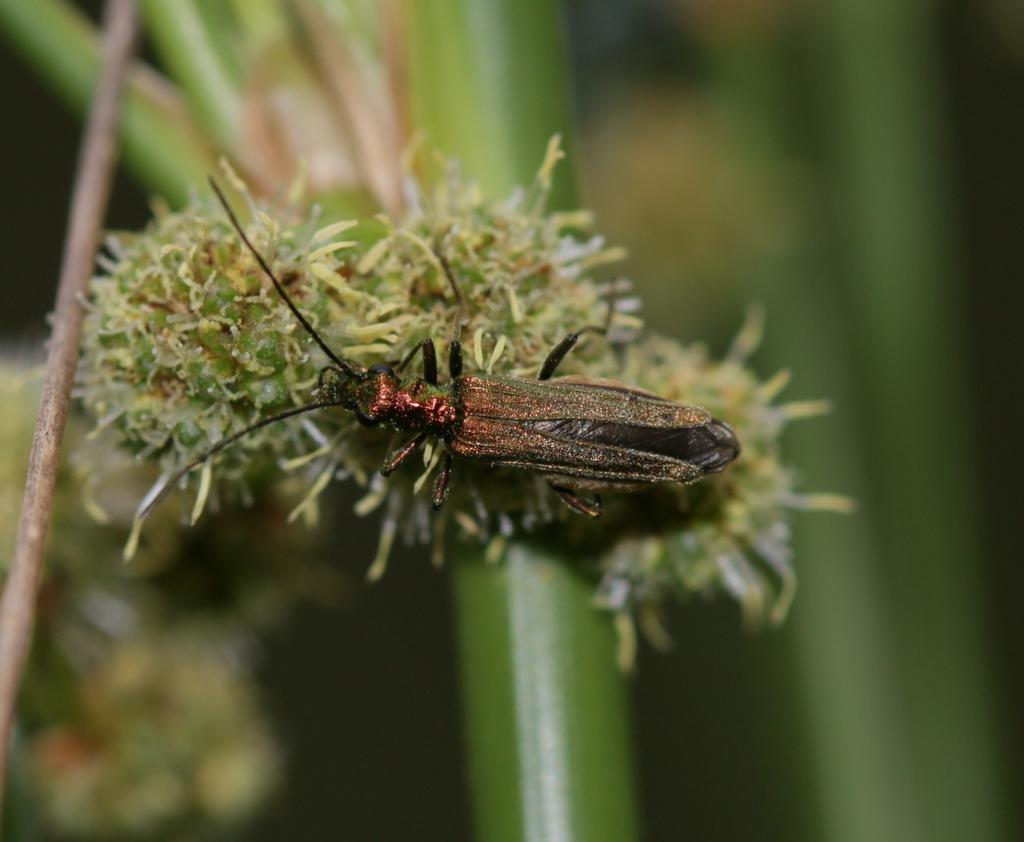What type of creature is in the image? There is an insect in the image. What is the insect doing in the image? The insect is laying on a plant. How is the background of the image depicted? The background of the plant is blurred. How many kittens are playing on the sheet in the image? There are no kittens or sheets present in the image; it features an insect laying on a plant with a blurred background. 